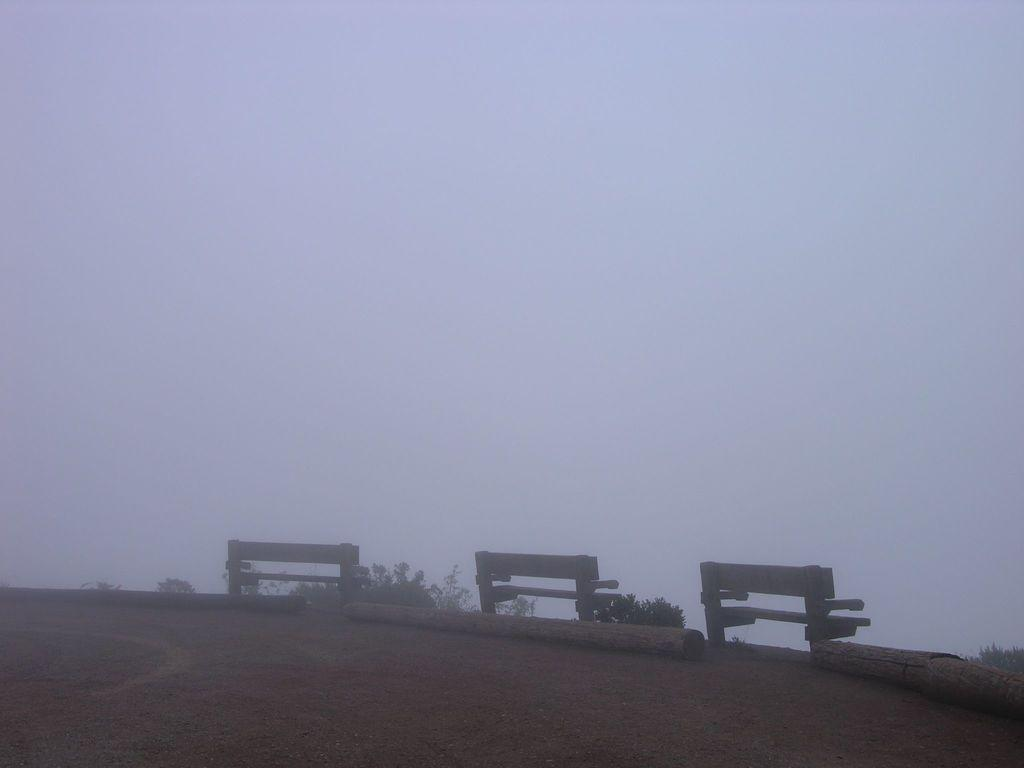How many benches are present in the image? There are three benches in the image. Where are the benches located? The benches are on the land. What atmospheric condition can be observed in the image? A: There is fog visible in the image. What type of vest is the turkey wearing in the image? There is no turkey or vest present in the image. 